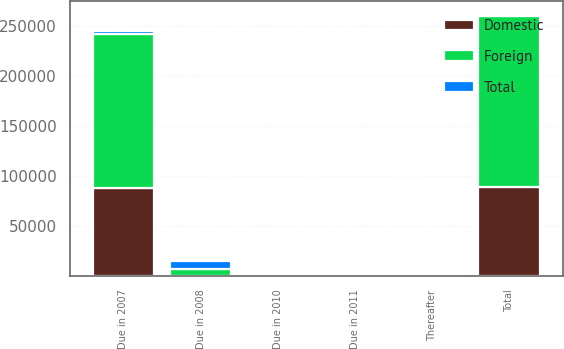Convert chart. <chart><loc_0><loc_0><loc_500><loc_500><stacked_bar_chart><ecel><fcel>Due in 2007<fcel>Due in 2008<fcel>Due in 2010<fcel>Due in 2011<fcel>Thereafter<fcel>Total<nl><fcel>Foreign<fcel>154509<fcel>7283<fcel>2179<fcel>807<fcel>959<fcel>170327<nl><fcel>Domestic<fcel>88396<fcel>218<fcel>1<fcel>2<fcel>1187<fcel>89804<nl><fcel>Total<fcel>2162.5<fcel>7501<fcel>2180<fcel>809<fcel>2146<fcel>2162.5<nl></chart> 